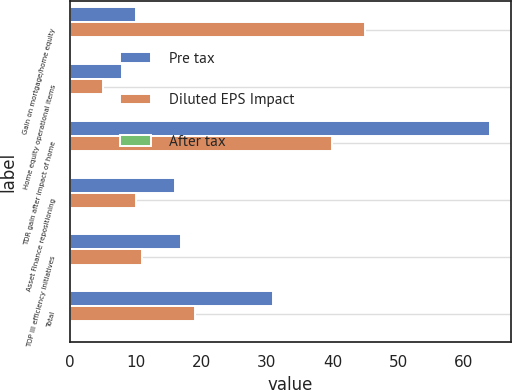<chart> <loc_0><loc_0><loc_500><loc_500><stacked_bar_chart><ecel><fcel>Gain on mortgage/home equity<fcel>Home equity operational items<fcel>TDR gain after impact of home<fcel>Asset Finance repositioning<fcel>TOP III efficiency initiatives<fcel>Total<nl><fcel>Pre tax<fcel>10<fcel>8<fcel>64<fcel>16<fcel>17<fcel>31<nl><fcel>Diluted EPS Impact<fcel>45<fcel>5<fcel>40<fcel>10<fcel>11<fcel>19<nl><fcel>After tax<fcel>0.09<fcel>0.01<fcel>0.08<fcel>0.02<fcel>0.02<fcel>0.04<nl></chart> 